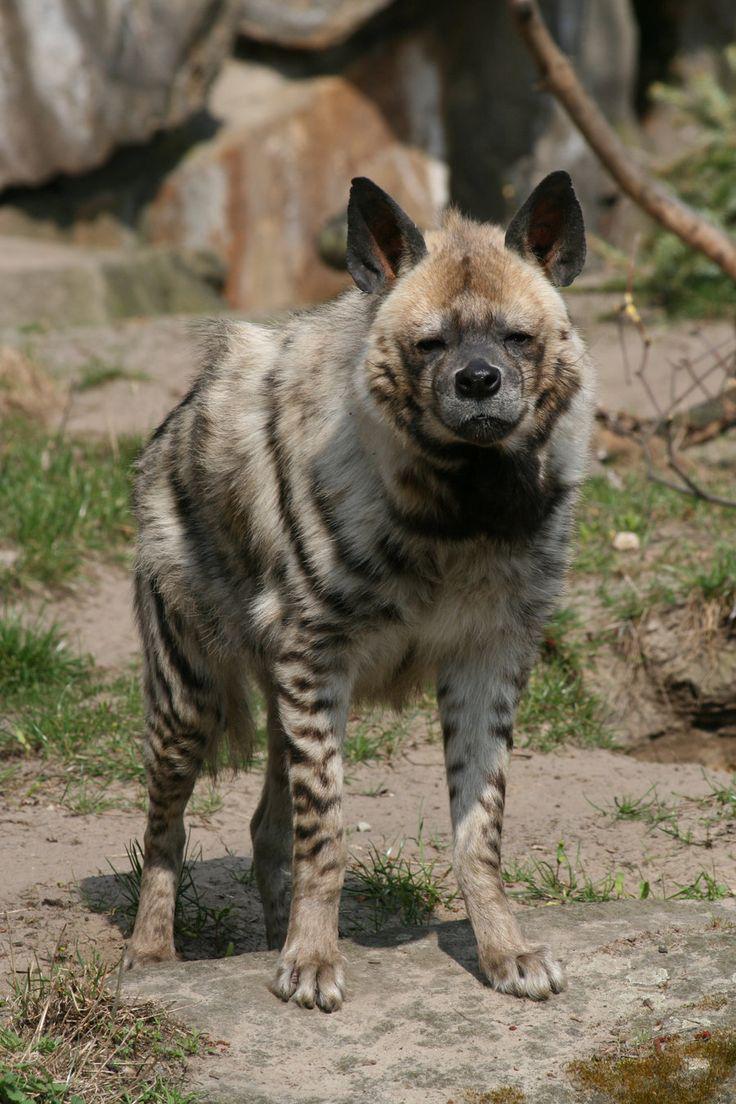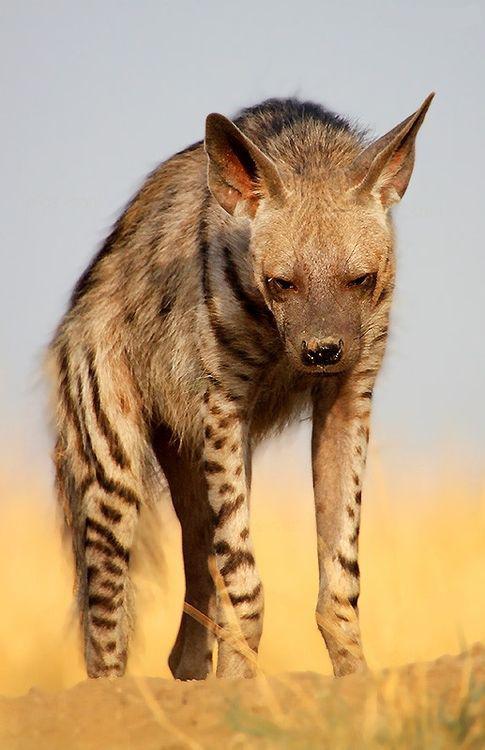The first image is the image on the left, the second image is the image on the right. Given the left and right images, does the statement "There is an animal with its mouth open in one of the images." hold true? Answer yes or no. No. 